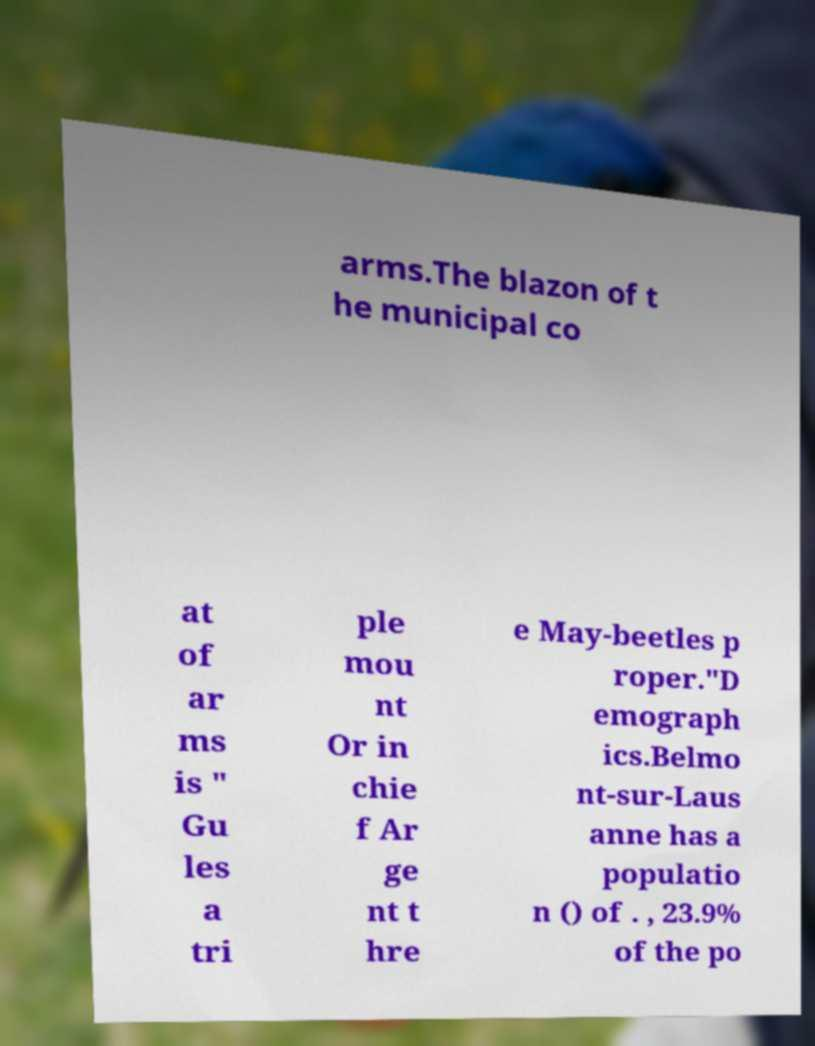I need the written content from this picture converted into text. Can you do that? arms.The blazon of t he municipal co at of ar ms is " Gu les a tri ple mou nt Or in chie f Ar ge nt t hre e May-beetles p roper."D emograph ics.Belmo nt-sur-Laus anne has a populatio n () of . , 23.9% of the po 